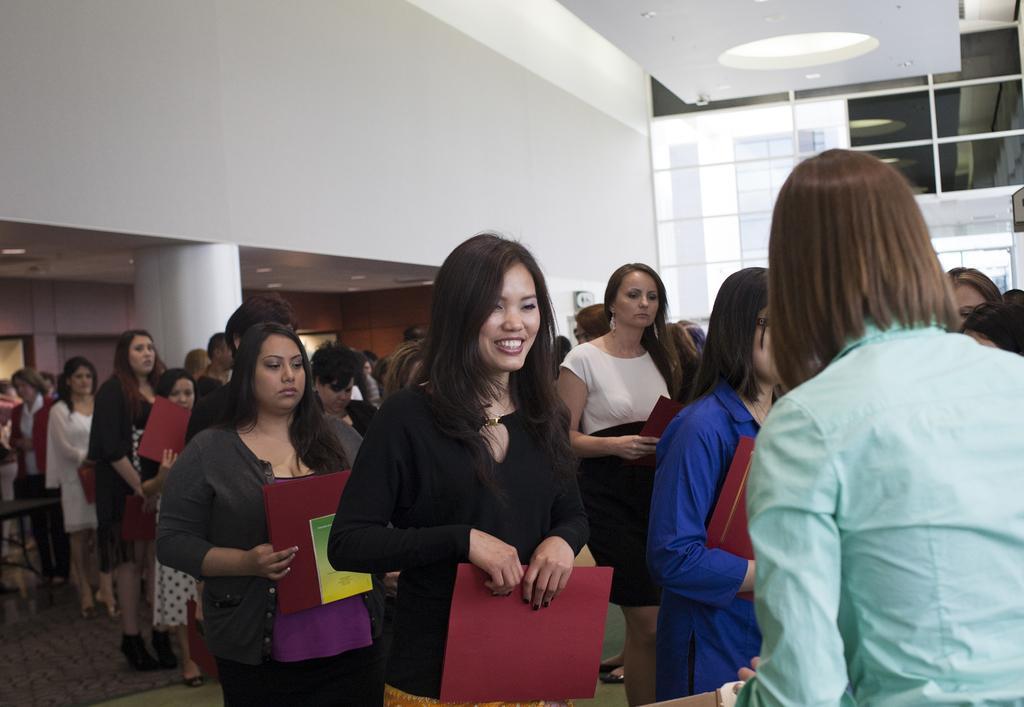How would you summarize this image in a sentence or two? In this picture there are women standing in a queue, holding files in their hands which were in red color. We can observe white color pillar and a wall here. In the background there is a glass window. 